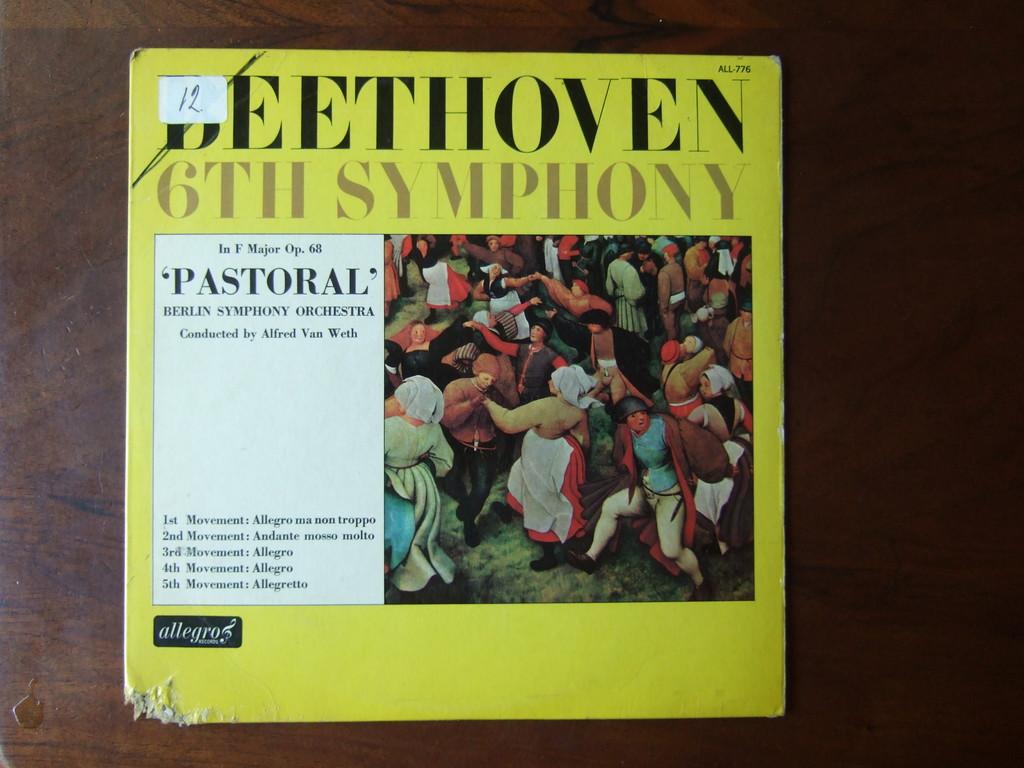What is printed in the line underneath the word "beethoven" in the title of this music album?
Keep it short and to the point. 6th symphony. 